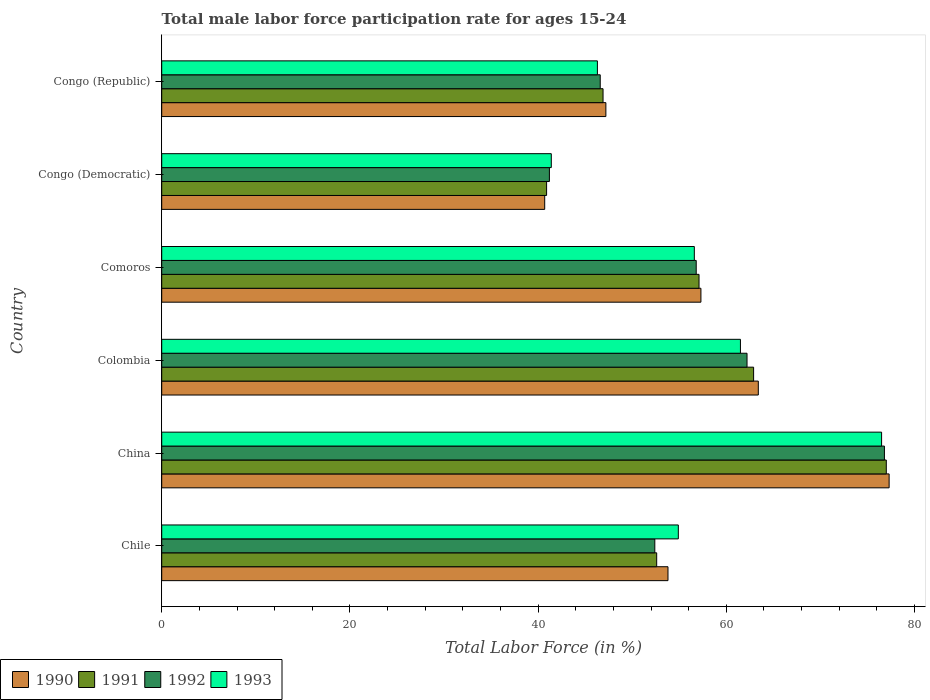How many different coloured bars are there?
Give a very brief answer. 4. Are the number of bars per tick equal to the number of legend labels?
Offer a terse response. Yes. Are the number of bars on each tick of the Y-axis equal?
Your answer should be very brief. Yes. How many bars are there on the 2nd tick from the bottom?
Give a very brief answer. 4. What is the label of the 2nd group of bars from the top?
Ensure brevity in your answer.  Congo (Democratic). In how many cases, is the number of bars for a given country not equal to the number of legend labels?
Your answer should be compact. 0. What is the male labor force participation rate in 1992 in Chile?
Your answer should be compact. 52.4. Across all countries, what is the minimum male labor force participation rate in 1991?
Offer a very short reply. 40.9. In which country was the male labor force participation rate in 1991 minimum?
Your answer should be compact. Congo (Democratic). What is the total male labor force participation rate in 1991 in the graph?
Offer a terse response. 337.4. What is the difference between the male labor force participation rate in 1990 in China and that in Comoros?
Your answer should be very brief. 20. What is the difference between the male labor force participation rate in 1992 in Congo (Democratic) and the male labor force participation rate in 1991 in Colombia?
Your answer should be very brief. -21.7. What is the average male labor force participation rate in 1992 per country?
Offer a very short reply. 56. What is the difference between the male labor force participation rate in 1991 and male labor force participation rate in 1993 in Comoros?
Offer a very short reply. 0.5. What is the ratio of the male labor force participation rate in 1990 in Comoros to that in Congo (Republic)?
Offer a terse response. 1.21. What is the difference between the highest and the second highest male labor force participation rate in 1990?
Make the answer very short. 13.9. What is the difference between the highest and the lowest male labor force participation rate in 1992?
Ensure brevity in your answer.  35.6. Is the sum of the male labor force participation rate in 1993 in Comoros and Congo (Democratic) greater than the maximum male labor force participation rate in 1992 across all countries?
Give a very brief answer. Yes. How many bars are there?
Offer a very short reply. 24. Are all the bars in the graph horizontal?
Provide a short and direct response. Yes. Are the values on the major ticks of X-axis written in scientific E-notation?
Ensure brevity in your answer.  No. Does the graph contain any zero values?
Keep it short and to the point. No. Does the graph contain grids?
Give a very brief answer. No. Where does the legend appear in the graph?
Your answer should be very brief. Bottom left. How many legend labels are there?
Make the answer very short. 4. How are the legend labels stacked?
Offer a very short reply. Horizontal. What is the title of the graph?
Offer a terse response. Total male labor force participation rate for ages 15-24. Does "1964" appear as one of the legend labels in the graph?
Keep it short and to the point. No. What is the label or title of the Y-axis?
Provide a succinct answer. Country. What is the Total Labor Force (in %) in 1990 in Chile?
Your answer should be very brief. 53.8. What is the Total Labor Force (in %) in 1991 in Chile?
Make the answer very short. 52.6. What is the Total Labor Force (in %) of 1992 in Chile?
Make the answer very short. 52.4. What is the Total Labor Force (in %) in 1993 in Chile?
Your answer should be very brief. 54.9. What is the Total Labor Force (in %) of 1990 in China?
Keep it short and to the point. 77.3. What is the Total Labor Force (in %) in 1992 in China?
Provide a succinct answer. 76.8. What is the Total Labor Force (in %) in 1993 in China?
Provide a short and direct response. 76.5. What is the Total Labor Force (in %) of 1990 in Colombia?
Offer a terse response. 63.4. What is the Total Labor Force (in %) in 1991 in Colombia?
Your answer should be compact. 62.9. What is the Total Labor Force (in %) in 1992 in Colombia?
Make the answer very short. 62.2. What is the Total Labor Force (in %) of 1993 in Colombia?
Provide a succinct answer. 61.5. What is the Total Labor Force (in %) in 1990 in Comoros?
Offer a terse response. 57.3. What is the Total Labor Force (in %) in 1991 in Comoros?
Make the answer very short. 57.1. What is the Total Labor Force (in %) of 1992 in Comoros?
Provide a short and direct response. 56.8. What is the Total Labor Force (in %) of 1993 in Comoros?
Your response must be concise. 56.6. What is the Total Labor Force (in %) in 1990 in Congo (Democratic)?
Provide a short and direct response. 40.7. What is the Total Labor Force (in %) in 1991 in Congo (Democratic)?
Make the answer very short. 40.9. What is the Total Labor Force (in %) of 1992 in Congo (Democratic)?
Ensure brevity in your answer.  41.2. What is the Total Labor Force (in %) in 1993 in Congo (Democratic)?
Offer a terse response. 41.4. What is the Total Labor Force (in %) of 1990 in Congo (Republic)?
Your response must be concise. 47.2. What is the Total Labor Force (in %) in 1991 in Congo (Republic)?
Your response must be concise. 46.9. What is the Total Labor Force (in %) of 1992 in Congo (Republic)?
Ensure brevity in your answer.  46.6. What is the Total Labor Force (in %) in 1993 in Congo (Republic)?
Your response must be concise. 46.3. Across all countries, what is the maximum Total Labor Force (in %) in 1990?
Offer a terse response. 77.3. Across all countries, what is the maximum Total Labor Force (in %) of 1991?
Give a very brief answer. 77. Across all countries, what is the maximum Total Labor Force (in %) in 1992?
Offer a very short reply. 76.8. Across all countries, what is the maximum Total Labor Force (in %) of 1993?
Offer a terse response. 76.5. Across all countries, what is the minimum Total Labor Force (in %) in 1990?
Make the answer very short. 40.7. Across all countries, what is the minimum Total Labor Force (in %) in 1991?
Offer a terse response. 40.9. Across all countries, what is the minimum Total Labor Force (in %) of 1992?
Ensure brevity in your answer.  41.2. Across all countries, what is the minimum Total Labor Force (in %) in 1993?
Provide a short and direct response. 41.4. What is the total Total Labor Force (in %) of 1990 in the graph?
Make the answer very short. 339.7. What is the total Total Labor Force (in %) of 1991 in the graph?
Your response must be concise. 337.4. What is the total Total Labor Force (in %) in 1992 in the graph?
Ensure brevity in your answer.  336. What is the total Total Labor Force (in %) in 1993 in the graph?
Offer a terse response. 337.2. What is the difference between the Total Labor Force (in %) in 1990 in Chile and that in China?
Offer a terse response. -23.5. What is the difference between the Total Labor Force (in %) in 1991 in Chile and that in China?
Ensure brevity in your answer.  -24.4. What is the difference between the Total Labor Force (in %) in 1992 in Chile and that in China?
Offer a very short reply. -24.4. What is the difference between the Total Labor Force (in %) in 1993 in Chile and that in China?
Make the answer very short. -21.6. What is the difference between the Total Labor Force (in %) of 1992 in Chile and that in Colombia?
Offer a very short reply. -9.8. What is the difference between the Total Labor Force (in %) of 1993 in Chile and that in Colombia?
Ensure brevity in your answer.  -6.6. What is the difference between the Total Labor Force (in %) in 1990 in Chile and that in Comoros?
Ensure brevity in your answer.  -3.5. What is the difference between the Total Labor Force (in %) of 1991 in Chile and that in Comoros?
Give a very brief answer. -4.5. What is the difference between the Total Labor Force (in %) of 1993 in Chile and that in Comoros?
Offer a very short reply. -1.7. What is the difference between the Total Labor Force (in %) in 1990 in Chile and that in Congo (Democratic)?
Provide a succinct answer. 13.1. What is the difference between the Total Labor Force (in %) of 1991 in Chile and that in Congo (Democratic)?
Ensure brevity in your answer.  11.7. What is the difference between the Total Labor Force (in %) in 1993 in Chile and that in Congo (Democratic)?
Make the answer very short. 13.5. What is the difference between the Total Labor Force (in %) in 1990 in Chile and that in Congo (Republic)?
Offer a very short reply. 6.6. What is the difference between the Total Labor Force (in %) in 1992 in Chile and that in Congo (Republic)?
Provide a succinct answer. 5.8. What is the difference between the Total Labor Force (in %) in 1993 in Chile and that in Congo (Republic)?
Make the answer very short. 8.6. What is the difference between the Total Labor Force (in %) in 1990 in China and that in Colombia?
Your response must be concise. 13.9. What is the difference between the Total Labor Force (in %) in 1991 in China and that in Colombia?
Offer a terse response. 14.1. What is the difference between the Total Labor Force (in %) of 1990 in China and that in Comoros?
Make the answer very short. 20. What is the difference between the Total Labor Force (in %) in 1990 in China and that in Congo (Democratic)?
Offer a terse response. 36.6. What is the difference between the Total Labor Force (in %) in 1991 in China and that in Congo (Democratic)?
Ensure brevity in your answer.  36.1. What is the difference between the Total Labor Force (in %) of 1992 in China and that in Congo (Democratic)?
Your response must be concise. 35.6. What is the difference between the Total Labor Force (in %) of 1993 in China and that in Congo (Democratic)?
Your response must be concise. 35.1. What is the difference between the Total Labor Force (in %) in 1990 in China and that in Congo (Republic)?
Your answer should be compact. 30.1. What is the difference between the Total Labor Force (in %) of 1991 in China and that in Congo (Republic)?
Ensure brevity in your answer.  30.1. What is the difference between the Total Labor Force (in %) in 1992 in China and that in Congo (Republic)?
Your answer should be compact. 30.2. What is the difference between the Total Labor Force (in %) in 1993 in China and that in Congo (Republic)?
Provide a short and direct response. 30.2. What is the difference between the Total Labor Force (in %) of 1991 in Colombia and that in Comoros?
Ensure brevity in your answer.  5.8. What is the difference between the Total Labor Force (in %) in 1992 in Colombia and that in Comoros?
Ensure brevity in your answer.  5.4. What is the difference between the Total Labor Force (in %) of 1993 in Colombia and that in Comoros?
Give a very brief answer. 4.9. What is the difference between the Total Labor Force (in %) of 1990 in Colombia and that in Congo (Democratic)?
Keep it short and to the point. 22.7. What is the difference between the Total Labor Force (in %) in 1992 in Colombia and that in Congo (Democratic)?
Give a very brief answer. 21. What is the difference between the Total Labor Force (in %) in 1993 in Colombia and that in Congo (Democratic)?
Your response must be concise. 20.1. What is the difference between the Total Labor Force (in %) in 1990 in Comoros and that in Congo (Democratic)?
Give a very brief answer. 16.6. What is the difference between the Total Labor Force (in %) in 1992 in Comoros and that in Congo (Democratic)?
Your answer should be very brief. 15.6. What is the difference between the Total Labor Force (in %) in 1993 in Comoros and that in Congo (Democratic)?
Your response must be concise. 15.2. What is the difference between the Total Labor Force (in %) in 1991 in Comoros and that in Congo (Republic)?
Make the answer very short. 10.2. What is the difference between the Total Labor Force (in %) in 1990 in Congo (Democratic) and that in Congo (Republic)?
Your response must be concise. -6.5. What is the difference between the Total Labor Force (in %) in 1993 in Congo (Democratic) and that in Congo (Republic)?
Provide a short and direct response. -4.9. What is the difference between the Total Labor Force (in %) of 1990 in Chile and the Total Labor Force (in %) of 1991 in China?
Give a very brief answer. -23.2. What is the difference between the Total Labor Force (in %) of 1990 in Chile and the Total Labor Force (in %) of 1993 in China?
Give a very brief answer. -22.7. What is the difference between the Total Labor Force (in %) in 1991 in Chile and the Total Labor Force (in %) in 1992 in China?
Ensure brevity in your answer.  -24.2. What is the difference between the Total Labor Force (in %) of 1991 in Chile and the Total Labor Force (in %) of 1993 in China?
Make the answer very short. -23.9. What is the difference between the Total Labor Force (in %) of 1992 in Chile and the Total Labor Force (in %) of 1993 in China?
Give a very brief answer. -24.1. What is the difference between the Total Labor Force (in %) in 1991 in Chile and the Total Labor Force (in %) in 1993 in Colombia?
Keep it short and to the point. -8.9. What is the difference between the Total Labor Force (in %) of 1992 in Chile and the Total Labor Force (in %) of 1993 in Colombia?
Offer a very short reply. -9.1. What is the difference between the Total Labor Force (in %) in 1990 in Chile and the Total Labor Force (in %) in 1992 in Comoros?
Provide a short and direct response. -3. What is the difference between the Total Labor Force (in %) in 1991 in Chile and the Total Labor Force (in %) in 1992 in Comoros?
Give a very brief answer. -4.2. What is the difference between the Total Labor Force (in %) in 1992 in Chile and the Total Labor Force (in %) in 1993 in Comoros?
Your answer should be compact. -4.2. What is the difference between the Total Labor Force (in %) of 1990 in Chile and the Total Labor Force (in %) of 1991 in Congo (Democratic)?
Your response must be concise. 12.9. What is the difference between the Total Labor Force (in %) in 1990 in Chile and the Total Labor Force (in %) in 1992 in Congo (Democratic)?
Offer a terse response. 12.6. What is the difference between the Total Labor Force (in %) of 1991 in Chile and the Total Labor Force (in %) of 1992 in Congo (Democratic)?
Make the answer very short. 11.4. What is the difference between the Total Labor Force (in %) of 1991 in Chile and the Total Labor Force (in %) of 1993 in Congo (Republic)?
Your answer should be very brief. 6.3. What is the difference between the Total Labor Force (in %) in 1992 in Chile and the Total Labor Force (in %) in 1993 in Congo (Republic)?
Ensure brevity in your answer.  6.1. What is the difference between the Total Labor Force (in %) in 1990 in China and the Total Labor Force (in %) in 1991 in Colombia?
Offer a very short reply. 14.4. What is the difference between the Total Labor Force (in %) in 1990 in China and the Total Labor Force (in %) in 1992 in Colombia?
Offer a very short reply. 15.1. What is the difference between the Total Labor Force (in %) in 1991 in China and the Total Labor Force (in %) in 1992 in Colombia?
Keep it short and to the point. 14.8. What is the difference between the Total Labor Force (in %) in 1991 in China and the Total Labor Force (in %) in 1993 in Colombia?
Offer a very short reply. 15.5. What is the difference between the Total Labor Force (in %) in 1992 in China and the Total Labor Force (in %) in 1993 in Colombia?
Ensure brevity in your answer.  15.3. What is the difference between the Total Labor Force (in %) of 1990 in China and the Total Labor Force (in %) of 1991 in Comoros?
Your answer should be very brief. 20.2. What is the difference between the Total Labor Force (in %) in 1990 in China and the Total Labor Force (in %) in 1992 in Comoros?
Offer a very short reply. 20.5. What is the difference between the Total Labor Force (in %) of 1990 in China and the Total Labor Force (in %) of 1993 in Comoros?
Make the answer very short. 20.7. What is the difference between the Total Labor Force (in %) in 1991 in China and the Total Labor Force (in %) in 1992 in Comoros?
Your answer should be very brief. 20.2. What is the difference between the Total Labor Force (in %) of 1991 in China and the Total Labor Force (in %) of 1993 in Comoros?
Make the answer very short. 20.4. What is the difference between the Total Labor Force (in %) in 1992 in China and the Total Labor Force (in %) in 1993 in Comoros?
Offer a terse response. 20.2. What is the difference between the Total Labor Force (in %) in 1990 in China and the Total Labor Force (in %) in 1991 in Congo (Democratic)?
Your answer should be very brief. 36.4. What is the difference between the Total Labor Force (in %) of 1990 in China and the Total Labor Force (in %) of 1992 in Congo (Democratic)?
Keep it short and to the point. 36.1. What is the difference between the Total Labor Force (in %) of 1990 in China and the Total Labor Force (in %) of 1993 in Congo (Democratic)?
Give a very brief answer. 35.9. What is the difference between the Total Labor Force (in %) in 1991 in China and the Total Labor Force (in %) in 1992 in Congo (Democratic)?
Give a very brief answer. 35.8. What is the difference between the Total Labor Force (in %) in 1991 in China and the Total Labor Force (in %) in 1993 in Congo (Democratic)?
Give a very brief answer. 35.6. What is the difference between the Total Labor Force (in %) in 1992 in China and the Total Labor Force (in %) in 1993 in Congo (Democratic)?
Provide a short and direct response. 35.4. What is the difference between the Total Labor Force (in %) in 1990 in China and the Total Labor Force (in %) in 1991 in Congo (Republic)?
Ensure brevity in your answer.  30.4. What is the difference between the Total Labor Force (in %) of 1990 in China and the Total Labor Force (in %) of 1992 in Congo (Republic)?
Ensure brevity in your answer.  30.7. What is the difference between the Total Labor Force (in %) in 1990 in China and the Total Labor Force (in %) in 1993 in Congo (Republic)?
Your answer should be very brief. 31. What is the difference between the Total Labor Force (in %) in 1991 in China and the Total Labor Force (in %) in 1992 in Congo (Republic)?
Offer a terse response. 30.4. What is the difference between the Total Labor Force (in %) of 1991 in China and the Total Labor Force (in %) of 1993 in Congo (Republic)?
Offer a very short reply. 30.7. What is the difference between the Total Labor Force (in %) of 1992 in China and the Total Labor Force (in %) of 1993 in Congo (Republic)?
Keep it short and to the point. 30.5. What is the difference between the Total Labor Force (in %) of 1990 in Colombia and the Total Labor Force (in %) of 1991 in Comoros?
Your answer should be very brief. 6.3. What is the difference between the Total Labor Force (in %) of 1991 in Colombia and the Total Labor Force (in %) of 1993 in Comoros?
Your response must be concise. 6.3. What is the difference between the Total Labor Force (in %) of 1992 in Colombia and the Total Labor Force (in %) of 1993 in Comoros?
Ensure brevity in your answer.  5.6. What is the difference between the Total Labor Force (in %) in 1990 in Colombia and the Total Labor Force (in %) in 1992 in Congo (Democratic)?
Offer a very short reply. 22.2. What is the difference between the Total Labor Force (in %) in 1991 in Colombia and the Total Labor Force (in %) in 1992 in Congo (Democratic)?
Your response must be concise. 21.7. What is the difference between the Total Labor Force (in %) of 1992 in Colombia and the Total Labor Force (in %) of 1993 in Congo (Democratic)?
Keep it short and to the point. 20.8. What is the difference between the Total Labor Force (in %) in 1990 in Colombia and the Total Labor Force (in %) in 1993 in Congo (Republic)?
Make the answer very short. 17.1. What is the difference between the Total Labor Force (in %) of 1991 in Colombia and the Total Labor Force (in %) of 1992 in Congo (Republic)?
Keep it short and to the point. 16.3. What is the difference between the Total Labor Force (in %) in 1992 in Colombia and the Total Labor Force (in %) in 1993 in Congo (Republic)?
Provide a succinct answer. 15.9. What is the difference between the Total Labor Force (in %) of 1990 in Comoros and the Total Labor Force (in %) of 1991 in Congo (Democratic)?
Your response must be concise. 16.4. What is the difference between the Total Labor Force (in %) of 1990 in Comoros and the Total Labor Force (in %) of 1992 in Congo (Democratic)?
Your answer should be compact. 16.1. What is the difference between the Total Labor Force (in %) of 1991 in Comoros and the Total Labor Force (in %) of 1992 in Congo (Democratic)?
Your response must be concise. 15.9. What is the difference between the Total Labor Force (in %) in 1990 in Comoros and the Total Labor Force (in %) in 1991 in Congo (Republic)?
Your answer should be very brief. 10.4. What is the difference between the Total Labor Force (in %) of 1990 in Comoros and the Total Labor Force (in %) of 1992 in Congo (Republic)?
Your answer should be very brief. 10.7. What is the difference between the Total Labor Force (in %) in 1991 in Comoros and the Total Labor Force (in %) in 1992 in Congo (Republic)?
Make the answer very short. 10.5. What is the difference between the Total Labor Force (in %) of 1991 in Comoros and the Total Labor Force (in %) of 1993 in Congo (Republic)?
Your response must be concise. 10.8. What is the difference between the Total Labor Force (in %) in 1992 in Comoros and the Total Labor Force (in %) in 1993 in Congo (Republic)?
Offer a terse response. 10.5. What is the difference between the Total Labor Force (in %) of 1990 in Congo (Democratic) and the Total Labor Force (in %) of 1992 in Congo (Republic)?
Your response must be concise. -5.9. What is the difference between the Total Labor Force (in %) of 1990 in Congo (Democratic) and the Total Labor Force (in %) of 1993 in Congo (Republic)?
Ensure brevity in your answer.  -5.6. What is the difference between the Total Labor Force (in %) of 1992 in Congo (Democratic) and the Total Labor Force (in %) of 1993 in Congo (Republic)?
Your answer should be compact. -5.1. What is the average Total Labor Force (in %) of 1990 per country?
Provide a succinct answer. 56.62. What is the average Total Labor Force (in %) of 1991 per country?
Your answer should be very brief. 56.23. What is the average Total Labor Force (in %) in 1993 per country?
Provide a short and direct response. 56.2. What is the difference between the Total Labor Force (in %) of 1990 and Total Labor Force (in %) of 1991 in Chile?
Offer a very short reply. 1.2. What is the difference between the Total Labor Force (in %) in 1990 and Total Labor Force (in %) in 1992 in Chile?
Keep it short and to the point. 1.4. What is the difference between the Total Labor Force (in %) in 1991 and Total Labor Force (in %) in 1993 in Chile?
Provide a succinct answer. -2.3. What is the difference between the Total Labor Force (in %) of 1990 and Total Labor Force (in %) of 1991 in China?
Your answer should be very brief. 0.3. What is the difference between the Total Labor Force (in %) in 1990 and Total Labor Force (in %) in 1992 in China?
Your answer should be very brief. 0.5. What is the difference between the Total Labor Force (in %) of 1990 and Total Labor Force (in %) of 1993 in China?
Make the answer very short. 0.8. What is the difference between the Total Labor Force (in %) in 1991 and Total Labor Force (in %) in 1992 in China?
Keep it short and to the point. 0.2. What is the difference between the Total Labor Force (in %) in 1991 and Total Labor Force (in %) in 1993 in China?
Keep it short and to the point. 0.5. What is the difference between the Total Labor Force (in %) in 1992 and Total Labor Force (in %) in 1993 in China?
Your answer should be very brief. 0.3. What is the difference between the Total Labor Force (in %) of 1990 and Total Labor Force (in %) of 1992 in Colombia?
Your response must be concise. 1.2. What is the difference between the Total Labor Force (in %) of 1991 and Total Labor Force (in %) of 1992 in Colombia?
Give a very brief answer. 0.7. What is the difference between the Total Labor Force (in %) in 1990 and Total Labor Force (in %) in 1991 in Comoros?
Keep it short and to the point. 0.2. What is the difference between the Total Labor Force (in %) of 1991 and Total Labor Force (in %) of 1993 in Comoros?
Offer a terse response. 0.5. What is the difference between the Total Labor Force (in %) in 1992 and Total Labor Force (in %) in 1993 in Comoros?
Provide a succinct answer. 0.2. What is the difference between the Total Labor Force (in %) in 1990 and Total Labor Force (in %) in 1993 in Congo (Democratic)?
Provide a short and direct response. -0.7. What is the difference between the Total Labor Force (in %) of 1990 and Total Labor Force (in %) of 1992 in Congo (Republic)?
Your response must be concise. 0.6. What is the difference between the Total Labor Force (in %) of 1990 and Total Labor Force (in %) of 1993 in Congo (Republic)?
Offer a very short reply. 0.9. What is the difference between the Total Labor Force (in %) of 1991 and Total Labor Force (in %) of 1993 in Congo (Republic)?
Provide a succinct answer. 0.6. What is the ratio of the Total Labor Force (in %) in 1990 in Chile to that in China?
Offer a terse response. 0.7. What is the ratio of the Total Labor Force (in %) in 1991 in Chile to that in China?
Provide a succinct answer. 0.68. What is the ratio of the Total Labor Force (in %) in 1992 in Chile to that in China?
Give a very brief answer. 0.68. What is the ratio of the Total Labor Force (in %) in 1993 in Chile to that in China?
Your answer should be very brief. 0.72. What is the ratio of the Total Labor Force (in %) of 1990 in Chile to that in Colombia?
Make the answer very short. 0.85. What is the ratio of the Total Labor Force (in %) of 1991 in Chile to that in Colombia?
Make the answer very short. 0.84. What is the ratio of the Total Labor Force (in %) of 1992 in Chile to that in Colombia?
Provide a succinct answer. 0.84. What is the ratio of the Total Labor Force (in %) in 1993 in Chile to that in Colombia?
Your answer should be compact. 0.89. What is the ratio of the Total Labor Force (in %) in 1990 in Chile to that in Comoros?
Offer a terse response. 0.94. What is the ratio of the Total Labor Force (in %) in 1991 in Chile to that in Comoros?
Provide a succinct answer. 0.92. What is the ratio of the Total Labor Force (in %) of 1992 in Chile to that in Comoros?
Make the answer very short. 0.92. What is the ratio of the Total Labor Force (in %) of 1993 in Chile to that in Comoros?
Give a very brief answer. 0.97. What is the ratio of the Total Labor Force (in %) in 1990 in Chile to that in Congo (Democratic)?
Your answer should be compact. 1.32. What is the ratio of the Total Labor Force (in %) in 1991 in Chile to that in Congo (Democratic)?
Offer a terse response. 1.29. What is the ratio of the Total Labor Force (in %) of 1992 in Chile to that in Congo (Democratic)?
Your answer should be very brief. 1.27. What is the ratio of the Total Labor Force (in %) in 1993 in Chile to that in Congo (Democratic)?
Your answer should be very brief. 1.33. What is the ratio of the Total Labor Force (in %) of 1990 in Chile to that in Congo (Republic)?
Ensure brevity in your answer.  1.14. What is the ratio of the Total Labor Force (in %) of 1991 in Chile to that in Congo (Republic)?
Provide a short and direct response. 1.12. What is the ratio of the Total Labor Force (in %) in 1992 in Chile to that in Congo (Republic)?
Your answer should be very brief. 1.12. What is the ratio of the Total Labor Force (in %) of 1993 in Chile to that in Congo (Republic)?
Offer a very short reply. 1.19. What is the ratio of the Total Labor Force (in %) in 1990 in China to that in Colombia?
Give a very brief answer. 1.22. What is the ratio of the Total Labor Force (in %) in 1991 in China to that in Colombia?
Provide a short and direct response. 1.22. What is the ratio of the Total Labor Force (in %) in 1992 in China to that in Colombia?
Make the answer very short. 1.23. What is the ratio of the Total Labor Force (in %) in 1993 in China to that in Colombia?
Keep it short and to the point. 1.24. What is the ratio of the Total Labor Force (in %) in 1990 in China to that in Comoros?
Offer a terse response. 1.35. What is the ratio of the Total Labor Force (in %) of 1991 in China to that in Comoros?
Ensure brevity in your answer.  1.35. What is the ratio of the Total Labor Force (in %) in 1992 in China to that in Comoros?
Offer a very short reply. 1.35. What is the ratio of the Total Labor Force (in %) of 1993 in China to that in Comoros?
Your response must be concise. 1.35. What is the ratio of the Total Labor Force (in %) of 1990 in China to that in Congo (Democratic)?
Offer a terse response. 1.9. What is the ratio of the Total Labor Force (in %) of 1991 in China to that in Congo (Democratic)?
Your response must be concise. 1.88. What is the ratio of the Total Labor Force (in %) of 1992 in China to that in Congo (Democratic)?
Your answer should be very brief. 1.86. What is the ratio of the Total Labor Force (in %) in 1993 in China to that in Congo (Democratic)?
Provide a succinct answer. 1.85. What is the ratio of the Total Labor Force (in %) of 1990 in China to that in Congo (Republic)?
Give a very brief answer. 1.64. What is the ratio of the Total Labor Force (in %) in 1991 in China to that in Congo (Republic)?
Give a very brief answer. 1.64. What is the ratio of the Total Labor Force (in %) in 1992 in China to that in Congo (Republic)?
Give a very brief answer. 1.65. What is the ratio of the Total Labor Force (in %) of 1993 in China to that in Congo (Republic)?
Offer a very short reply. 1.65. What is the ratio of the Total Labor Force (in %) of 1990 in Colombia to that in Comoros?
Offer a terse response. 1.11. What is the ratio of the Total Labor Force (in %) in 1991 in Colombia to that in Comoros?
Provide a succinct answer. 1.1. What is the ratio of the Total Labor Force (in %) of 1992 in Colombia to that in Comoros?
Offer a very short reply. 1.1. What is the ratio of the Total Labor Force (in %) of 1993 in Colombia to that in Comoros?
Provide a short and direct response. 1.09. What is the ratio of the Total Labor Force (in %) of 1990 in Colombia to that in Congo (Democratic)?
Ensure brevity in your answer.  1.56. What is the ratio of the Total Labor Force (in %) of 1991 in Colombia to that in Congo (Democratic)?
Provide a short and direct response. 1.54. What is the ratio of the Total Labor Force (in %) in 1992 in Colombia to that in Congo (Democratic)?
Your response must be concise. 1.51. What is the ratio of the Total Labor Force (in %) of 1993 in Colombia to that in Congo (Democratic)?
Give a very brief answer. 1.49. What is the ratio of the Total Labor Force (in %) of 1990 in Colombia to that in Congo (Republic)?
Provide a succinct answer. 1.34. What is the ratio of the Total Labor Force (in %) in 1991 in Colombia to that in Congo (Republic)?
Your answer should be compact. 1.34. What is the ratio of the Total Labor Force (in %) in 1992 in Colombia to that in Congo (Republic)?
Provide a succinct answer. 1.33. What is the ratio of the Total Labor Force (in %) in 1993 in Colombia to that in Congo (Republic)?
Keep it short and to the point. 1.33. What is the ratio of the Total Labor Force (in %) in 1990 in Comoros to that in Congo (Democratic)?
Provide a succinct answer. 1.41. What is the ratio of the Total Labor Force (in %) of 1991 in Comoros to that in Congo (Democratic)?
Your answer should be very brief. 1.4. What is the ratio of the Total Labor Force (in %) in 1992 in Comoros to that in Congo (Democratic)?
Make the answer very short. 1.38. What is the ratio of the Total Labor Force (in %) of 1993 in Comoros to that in Congo (Democratic)?
Your response must be concise. 1.37. What is the ratio of the Total Labor Force (in %) in 1990 in Comoros to that in Congo (Republic)?
Your answer should be compact. 1.21. What is the ratio of the Total Labor Force (in %) in 1991 in Comoros to that in Congo (Republic)?
Ensure brevity in your answer.  1.22. What is the ratio of the Total Labor Force (in %) of 1992 in Comoros to that in Congo (Republic)?
Give a very brief answer. 1.22. What is the ratio of the Total Labor Force (in %) of 1993 in Comoros to that in Congo (Republic)?
Provide a short and direct response. 1.22. What is the ratio of the Total Labor Force (in %) of 1990 in Congo (Democratic) to that in Congo (Republic)?
Your answer should be very brief. 0.86. What is the ratio of the Total Labor Force (in %) in 1991 in Congo (Democratic) to that in Congo (Republic)?
Give a very brief answer. 0.87. What is the ratio of the Total Labor Force (in %) in 1992 in Congo (Democratic) to that in Congo (Republic)?
Your answer should be very brief. 0.88. What is the ratio of the Total Labor Force (in %) in 1993 in Congo (Democratic) to that in Congo (Republic)?
Ensure brevity in your answer.  0.89. What is the difference between the highest and the second highest Total Labor Force (in %) in 1990?
Keep it short and to the point. 13.9. What is the difference between the highest and the second highest Total Labor Force (in %) in 1993?
Your answer should be compact. 15. What is the difference between the highest and the lowest Total Labor Force (in %) of 1990?
Your answer should be compact. 36.6. What is the difference between the highest and the lowest Total Labor Force (in %) of 1991?
Your response must be concise. 36.1. What is the difference between the highest and the lowest Total Labor Force (in %) in 1992?
Provide a short and direct response. 35.6. What is the difference between the highest and the lowest Total Labor Force (in %) of 1993?
Your answer should be compact. 35.1. 